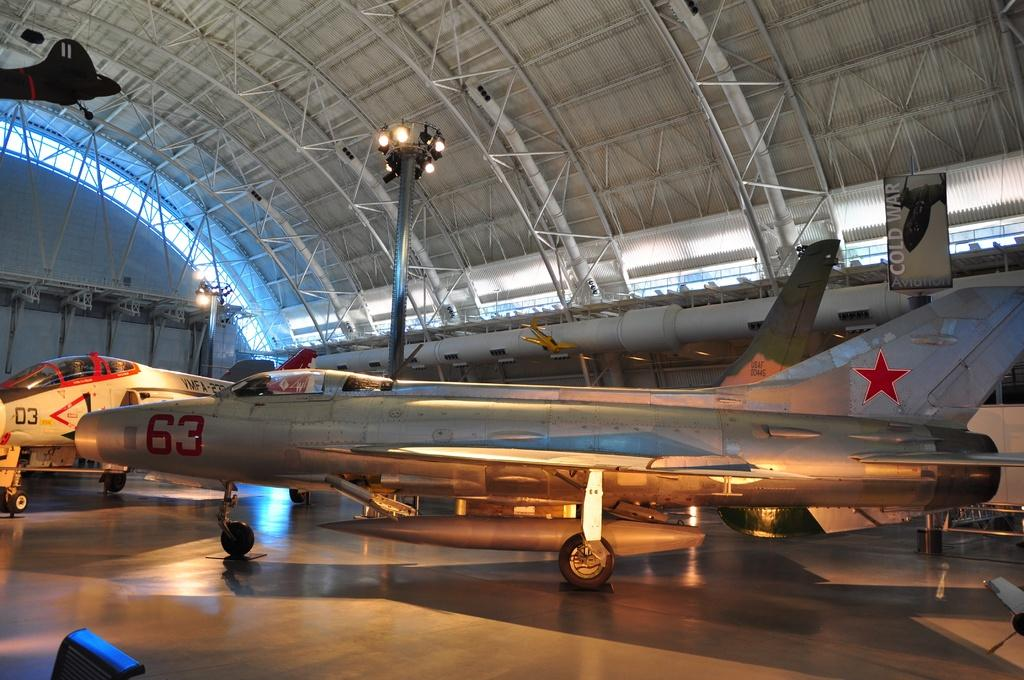Provide a one-sentence caption for the provided image. mant airplanes are inside a large building including a silver one with the number 63. 